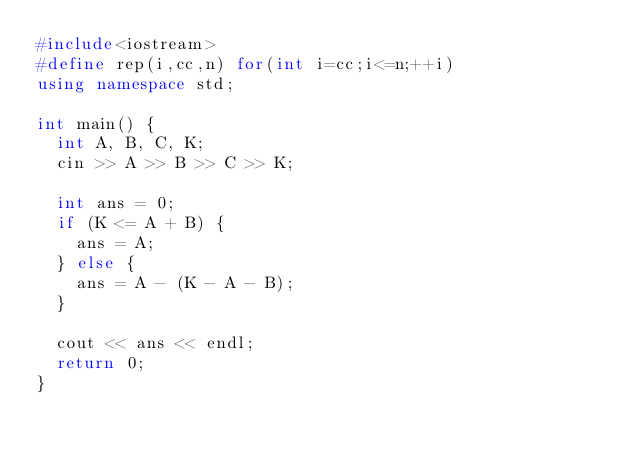<code> <loc_0><loc_0><loc_500><loc_500><_C++_>#include<iostream>
#define rep(i,cc,n) for(int i=cc;i<=n;++i)
using namespace std;

int main() {
  int A, B, C, K;
  cin >> A >> B >> C >> K;

  int ans = 0;
  if (K <= A + B) {
    ans = A;
  } else {
    ans = A - (K - A - B);
  }

  cout << ans << endl;
  return 0;
}
</code> 